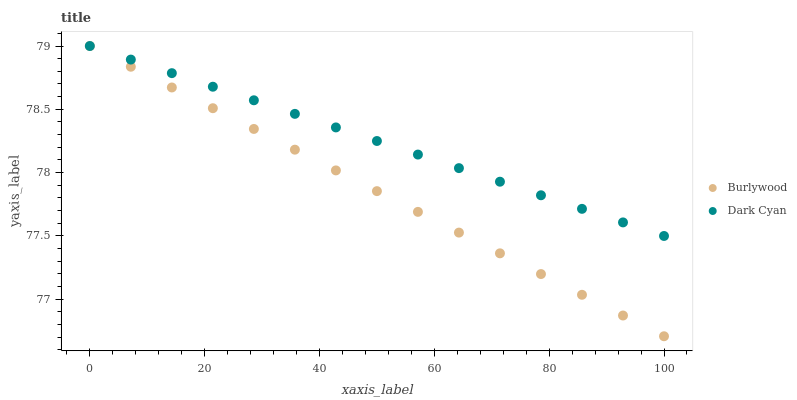Does Burlywood have the minimum area under the curve?
Answer yes or no. Yes. Does Dark Cyan have the maximum area under the curve?
Answer yes or no. Yes. Does Dark Cyan have the minimum area under the curve?
Answer yes or no. No. Is Dark Cyan the smoothest?
Answer yes or no. Yes. Is Burlywood the roughest?
Answer yes or no. Yes. Is Dark Cyan the roughest?
Answer yes or no. No. Does Burlywood have the lowest value?
Answer yes or no. Yes. Does Dark Cyan have the lowest value?
Answer yes or no. No. Does Dark Cyan have the highest value?
Answer yes or no. Yes. Does Dark Cyan intersect Burlywood?
Answer yes or no. Yes. Is Dark Cyan less than Burlywood?
Answer yes or no. No. Is Dark Cyan greater than Burlywood?
Answer yes or no. No. 